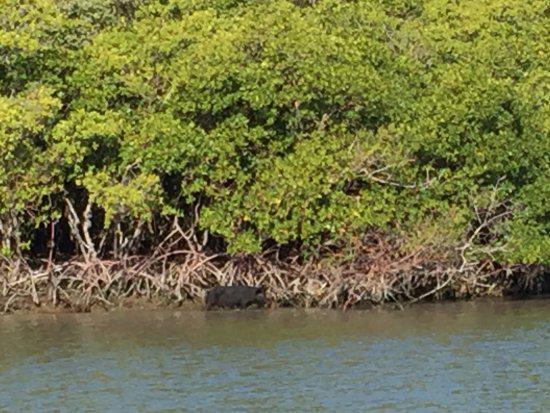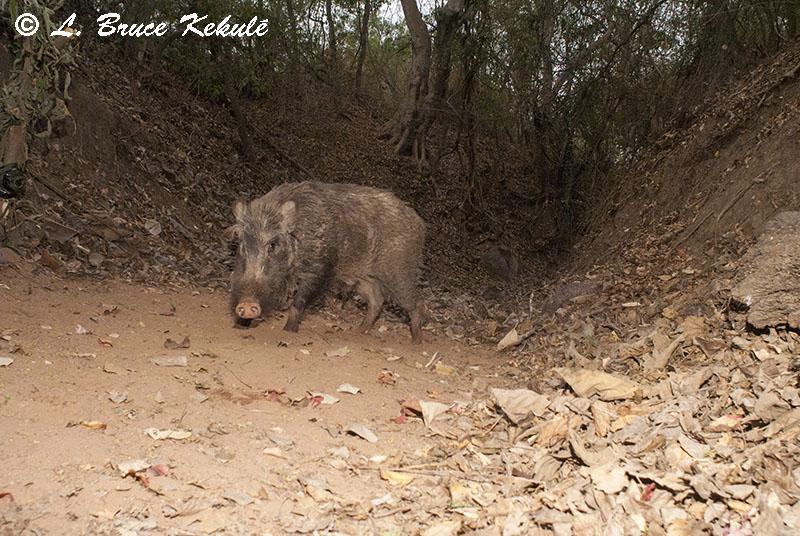The first image is the image on the left, the second image is the image on the right. Given the left and right images, does the statement "In at least one image there is a single boar facing right in the water next to the grassy bank." hold true? Answer yes or no. Yes. The first image is the image on the left, the second image is the image on the right. For the images displayed, is the sentence "One image shows a single forward-facing wild pig standing in an area that is not covered in water, and the other image shows at least one pig in water." factually correct? Answer yes or no. Yes. 